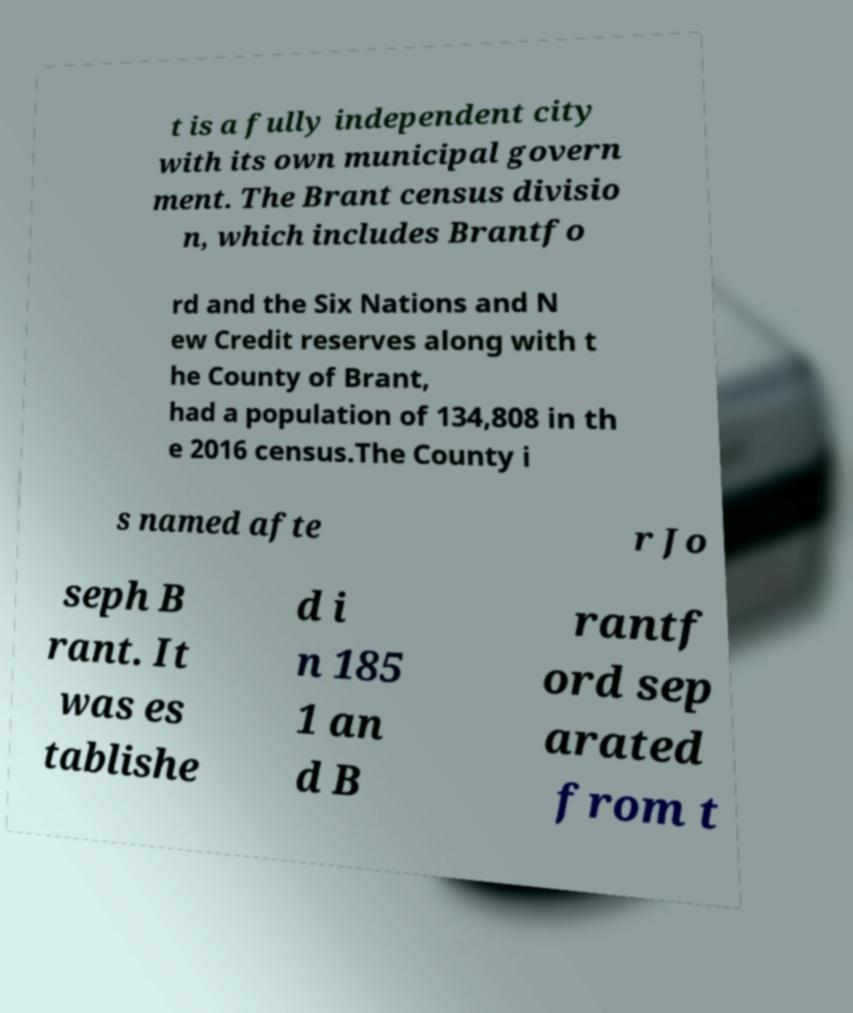Please identify and transcribe the text found in this image. t is a fully independent city with its own municipal govern ment. The Brant census divisio n, which includes Brantfo rd and the Six Nations and N ew Credit reserves along with t he County of Brant, had a population of 134,808 in th e 2016 census.The County i s named afte r Jo seph B rant. It was es tablishe d i n 185 1 an d B rantf ord sep arated from t 